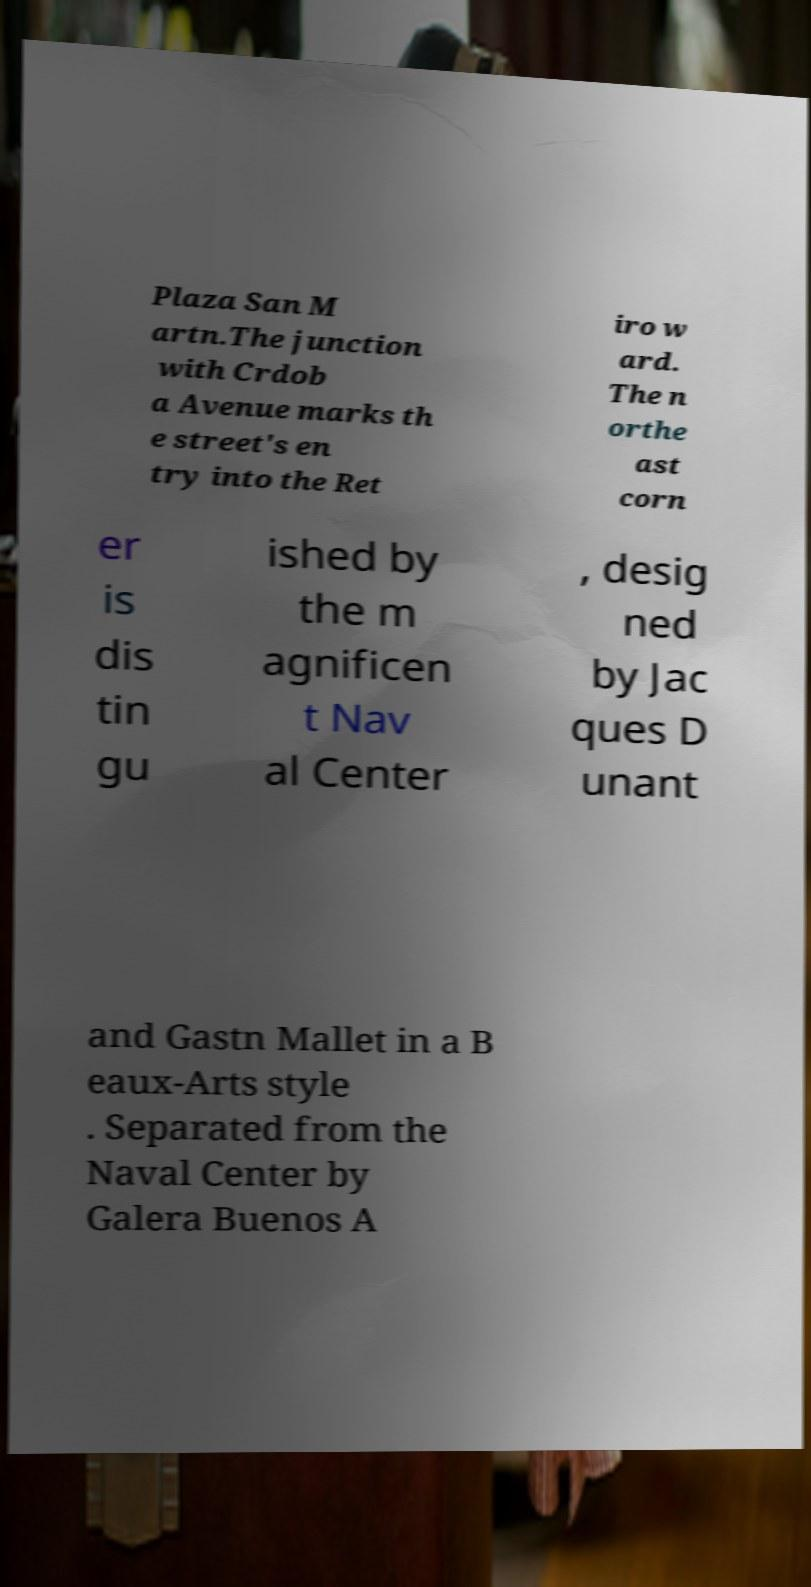Can you accurately transcribe the text from the provided image for me? Plaza San M artn.The junction with Crdob a Avenue marks th e street's en try into the Ret iro w ard. The n orthe ast corn er is dis tin gu ished by the m agnificen t Nav al Center , desig ned by Jac ques D unant and Gastn Mallet in a B eaux-Arts style . Separated from the Naval Center by Galera Buenos A 